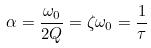<formula> <loc_0><loc_0><loc_500><loc_500>\alpha = \frac { \omega _ { 0 } } { 2 Q } = \zeta \omega _ { 0 } = \frac { 1 } { \tau }</formula> 